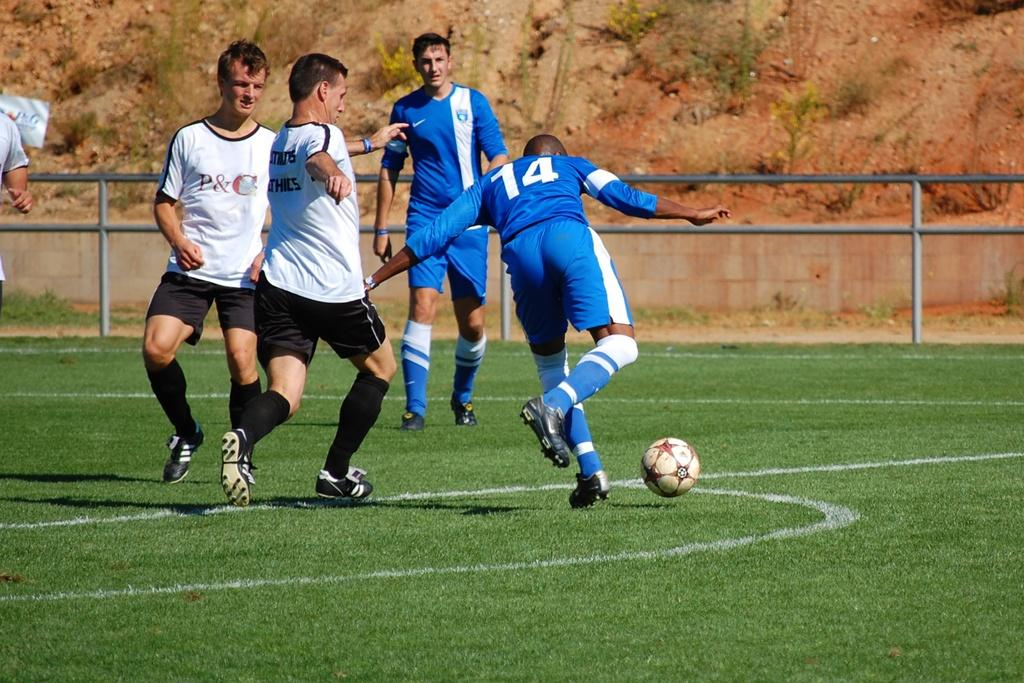<image>
Share a concise interpretation of the image provided. Two teams playing soccer, the white shirts representing P&C. 